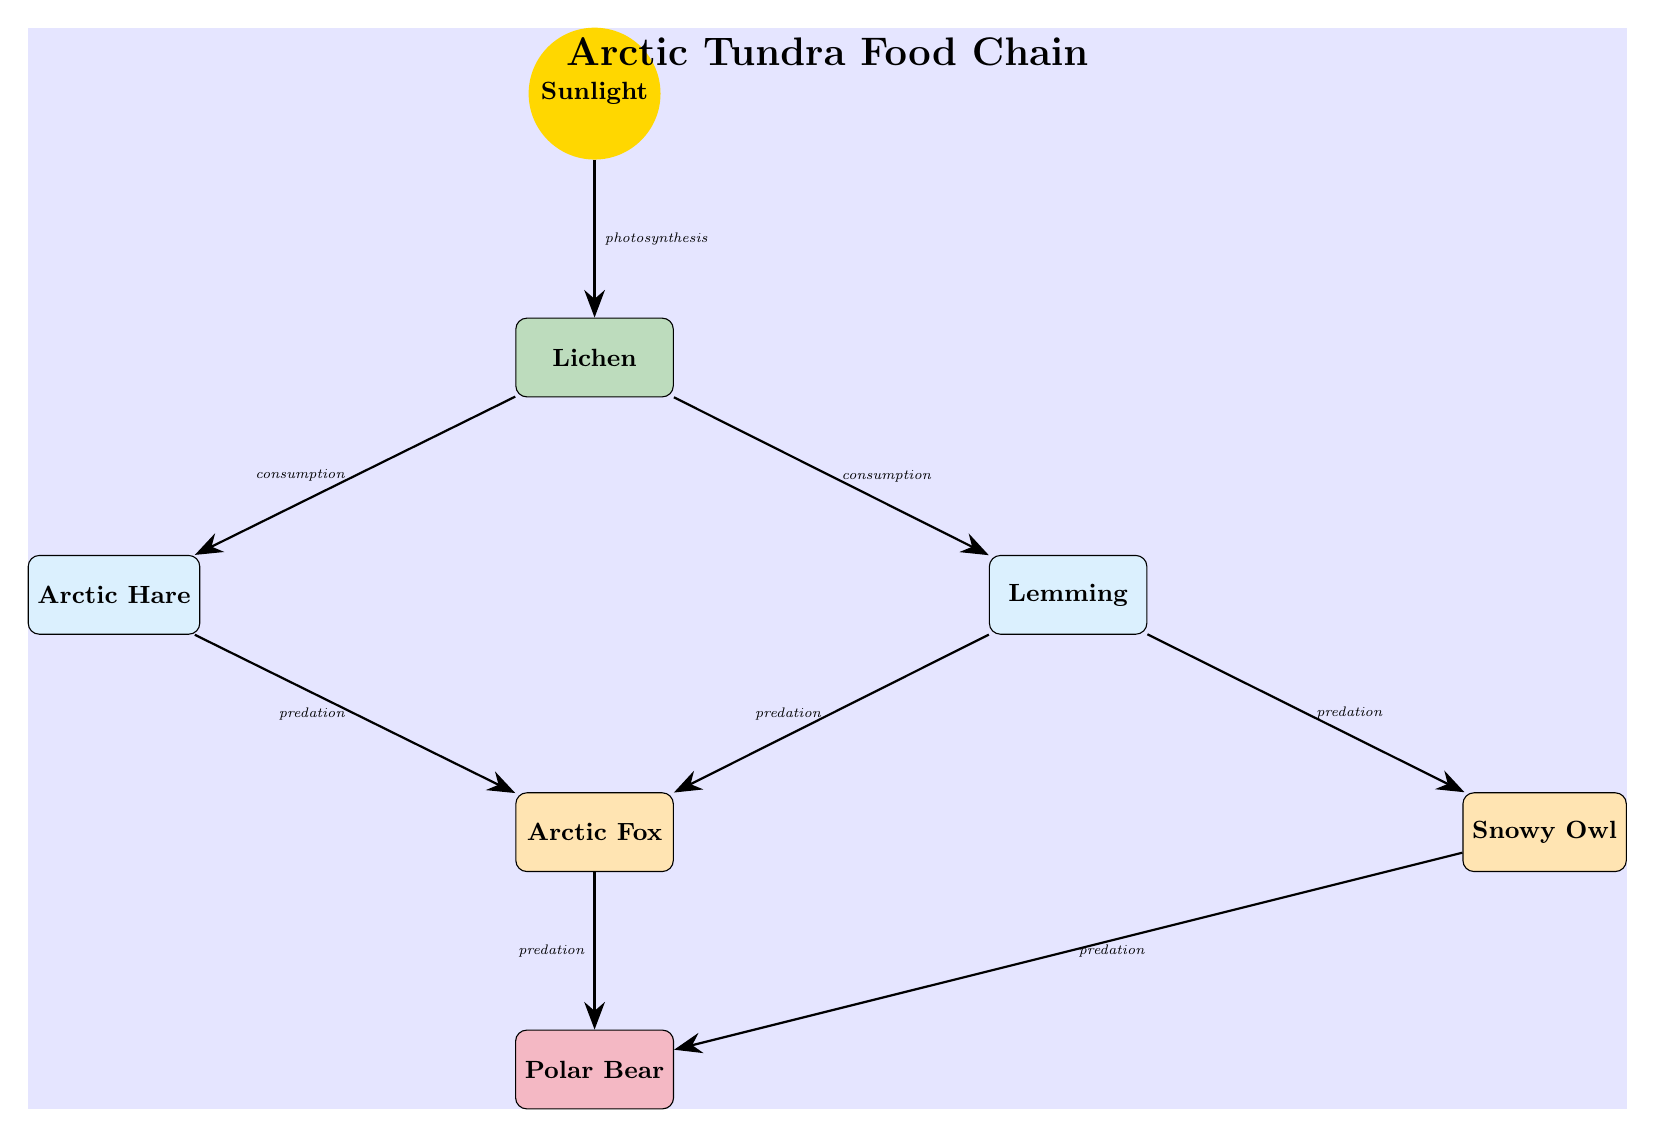What is the primary producer in the Arctic Tundra Food Chain? The diagram shows that the lichen is the first organism listed below the sunlight, which is the primary producer in the food chain.
Answer: Lichen How many primary consumers are in the food chain? The diagram lists two primary consumers, the Arctic Hare and the Lemming. Therefore, there are two primary consumers in the food chain.
Answer: 2 Who is the secondary consumer that preys on both the Lemming and the Arctic Hare? The Arctic Fox, which is shown below the Lemming and to the left of the diagram, is the secondary consumer that predates both the Lemming and the Arctic Hare.
Answer: Arctic Fox What type of relationship exists between the Arctic Fox and the Polar Bear? The diagram indicates a predation relationship with an arrow pointing from the Arctic Fox to the Polar Bear, meaning the Arctic Fox is preyed upon by the Polar Bear.
Answer: Predation What is the energy source for the entire food chain? The diagram represents sunlight as the primary energy source at the top, which provides energy for the entire food chain through the process of photosynthesis.
Answer: Sunlight Why do lemmings have a connection to two different secondary consumers? The diagram shows arrows pointing from lemmings to both the Arctic Fox and the Snowy Owl. This indicates that lemmings serve as food for both these secondary consumers in the food chain, highlighting their role as a crucial prey species.
Answer: They are food for both What does the arrow labeled 'photosynthesis' indicate? The arrow from the Sunlight to the Lichen signifies that lichen gains its energy through photosynthesis, which is the process of converting sunlight into chemical energy.
Answer: Photosynthesis What are the tertiary consumers in this food chain? The diagram illustrates the Polar Bear as a single tertiary consumer, depicted below the Arctic Fox and Snowy Owl. Therefore, the only tertiary consumer in this food chain is the Polar Bear.
Answer: Polar Bear 